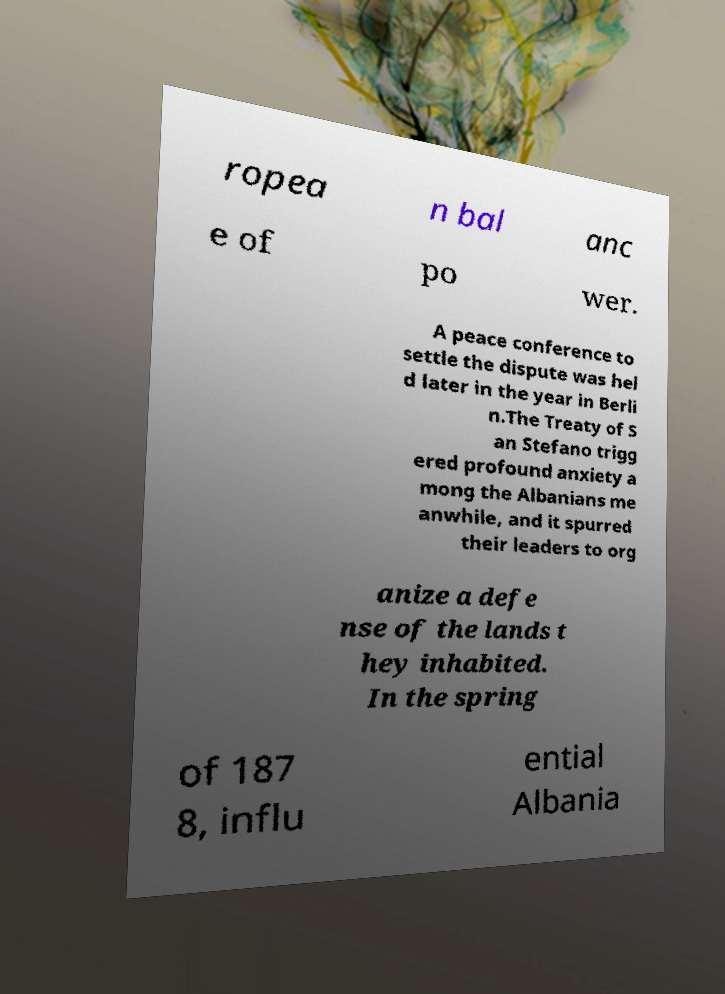For documentation purposes, I need the text within this image transcribed. Could you provide that? ropea n bal anc e of po wer. A peace conference to settle the dispute was hel d later in the year in Berli n.The Treaty of S an Stefano trigg ered profound anxiety a mong the Albanians me anwhile, and it spurred their leaders to org anize a defe nse of the lands t hey inhabited. In the spring of 187 8, influ ential Albania 